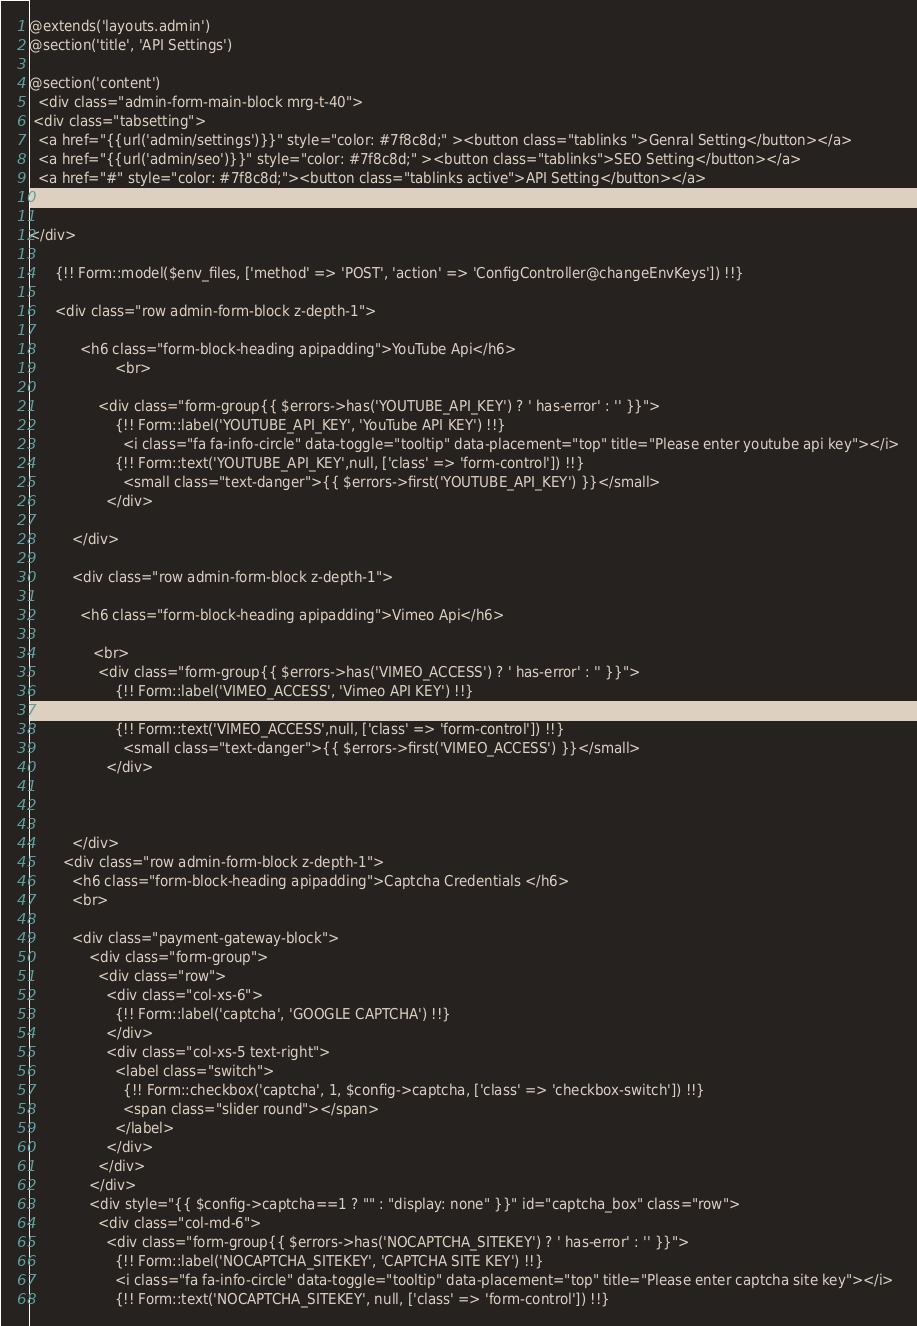<code> <loc_0><loc_0><loc_500><loc_500><_PHP_>@extends('layouts.admin')
@section('title', 'API Settings')

@section('content')
  <div class="admin-form-main-block mrg-t-40">
 <div class="tabsetting">
  <a href="{{url('admin/settings')}}" style="color: #7f8c8d;" ><button class="tablinks ">Genral Setting</button></a>
  <a href="{{url('admin/seo')}}" style="color: #7f8c8d;" ><button class="tablinks">SEO Setting</button></a>
  <a href="#" style="color: #7f8c8d;"><button class="tablinks active">API Setting</button></a>
  <a href="{{route('mail.getset')}}" style="color: #7f8c8d;"><button class="tablinks">Mail Setting</button></a>

</div>
  
      {!! Form::model($env_files, ['method' => 'POST', 'action' => 'ConfigController@changeEnvKeys']) !!}

      <div class="row admin-form-block z-depth-1">
       
            <h6 class="form-block-heading apipadding">YouTube Api</h6>
                    <br>
              
                <div class="form-group{{ $errors->has('YOUTUBE_API_KEY') ? ' has-error' : '' }}">
                    {!! Form::label('YOUTUBE_API_KEY', 'YouTube API KEY') !!}
                      <i class="fa fa-info-circle" data-toggle="tooltip" data-placement="top" title="Please enter youtube api key"></i>
                    {!! Form::text('YOUTUBE_API_KEY',null, ['class' => 'form-control']) !!}
                      <small class="text-danger">{{ $errors->first('YOUTUBE_API_KEY') }}</small>
                  </div>
             
          </div>

          <div class="row admin-form-block z-depth-1">
        
            <h6 class="form-block-heading apipadding">Vimeo Api</h6>
          
               <br>
                <div class="form-group{{ $errors->has('VIMEO_ACCESS') ? ' has-error' : '' }}">
                    {!! Form::label('VIMEO_ACCESS', 'Vimeo API KEY') !!}
                      <i class="fa fa-info-circle" data-toggle="tooltip" data-placement="top" title="Please enter Vimeo api key"></i>
                    {!! Form::text('VIMEO_ACCESS',null, ['class' => 'form-control']) !!}
                      <small class="text-danger">{{ $errors->first('VIMEO_ACCESS') }}</small>
                  </div>
                 
           
          
          </div>
        <div class="row admin-form-block z-depth-1">
          <h6 class="form-block-heading apipadding">Captcha Credentials </h6>
          <br>
              
          <div class="payment-gateway-block">
              <div class="form-group">
                <div class="row">
                  <div class="col-xs-6">
                    {!! Form::label('captcha', 'GOOGLE CAPTCHA') !!}
                  </div>
                  <div class="col-xs-5 text-right">
                    <label class="switch">
                      {!! Form::checkbox('captcha', 1, $config->captcha, ['class' => 'checkbox-switch']) !!}
                      <span class="slider round"></span>
                    </label>
                  </div>
                </div>
              </div>
              <div style="{{ $config->captcha==1 ? "" : "display: none" }}" id="captcha_box" class="row">
                <div class="col-md-6">
                  <div class="form-group{{ $errors->has('NOCAPTCHA_SITEKEY') ? ' has-error' : '' }}">
                    {!! Form::label('NOCAPTCHA_SITEKEY', 'CAPTCHA SITE KEY') !!}
                    <i class="fa fa-info-circle" data-toggle="tooltip" data-placement="top" title="Please enter captcha site key"></i>
                    {!! Form::text('NOCAPTCHA_SITEKEY', null, ['class' => 'form-control']) !!}</code> 